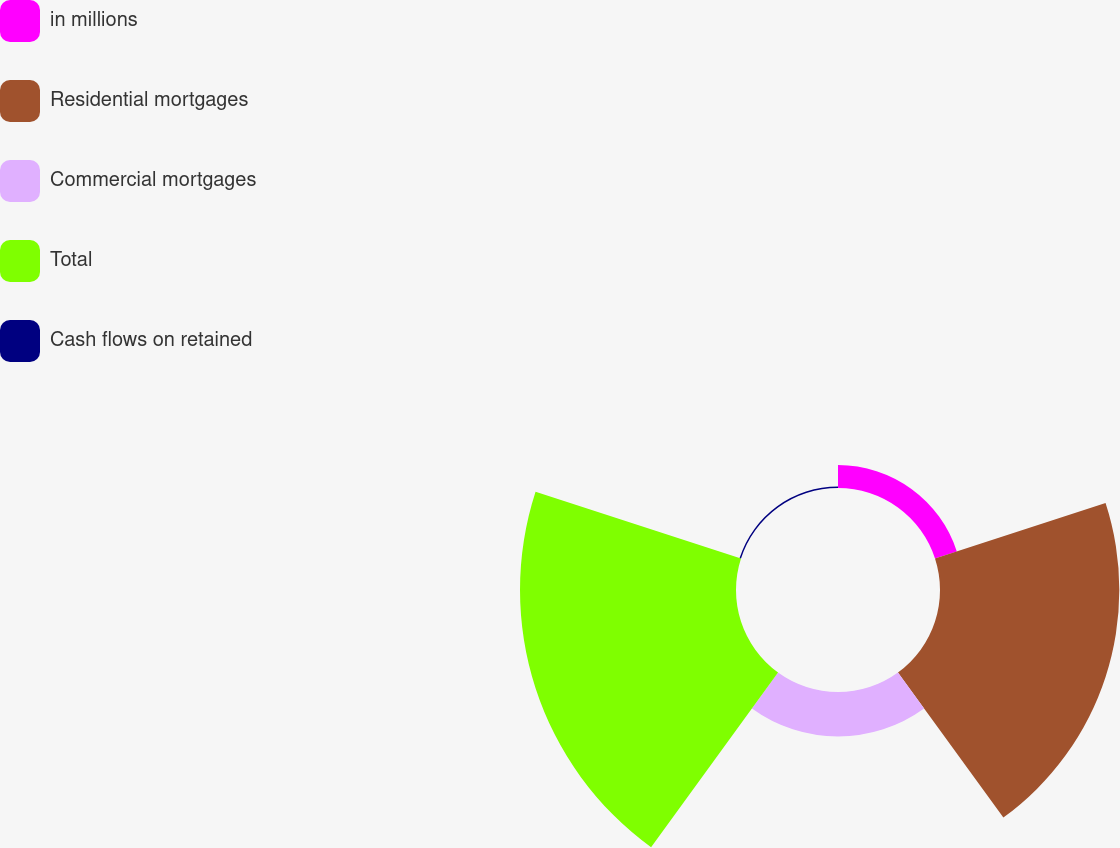Convert chart to OTSL. <chart><loc_0><loc_0><loc_500><loc_500><pie_chart><fcel>in millions<fcel>Residential mortgages<fcel>Commercial mortgages<fcel>Total<fcel>Cash flows on retained<nl><fcel>4.94%<fcel>38.63%<fcel>9.57%<fcel>46.53%<fcel>0.32%<nl></chart> 